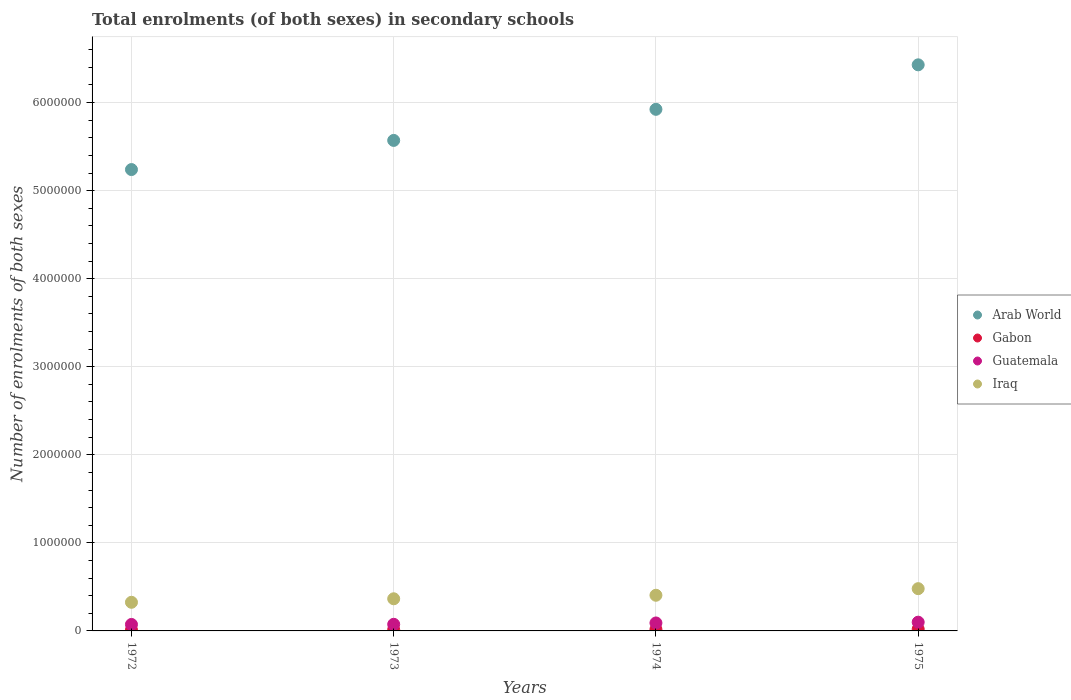How many different coloured dotlines are there?
Provide a succinct answer. 4. Is the number of dotlines equal to the number of legend labels?
Offer a terse response. Yes. What is the number of enrolments in secondary schools in Guatemala in 1974?
Your response must be concise. 9.05e+04. Across all years, what is the maximum number of enrolments in secondary schools in Guatemala?
Give a very brief answer. 9.92e+04. Across all years, what is the minimum number of enrolments in secondary schools in Guatemala?
Your answer should be very brief. 7.35e+04. In which year was the number of enrolments in secondary schools in Arab World maximum?
Make the answer very short. 1975. In which year was the number of enrolments in secondary schools in Arab World minimum?
Your answer should be very brief. 1972. What is the total number of enrolments in secondary schools in Gabon in the graph?
Your answer should be compact. 6.45e+04. What is the difference between the number of enrolments in secondary schools in Iraq in 1972 and that in 1975?
Provide a succinct answer. -1.55e+05. What is the difference between the number of enrolments in secondary schools in Arab World in 1973 and the number of enrolments in secondary schools in Gabon in 1975?
Ensure brevity in your answer.  5.55e+06. What is the average number of enrolments in secondary schools in Arab World per year?
Provide a succinct answer. 5.79e+06. In the year 1974, what is the difference between the number of enrolments in secondary schools in Arab World and number of enrolments in secondary schools in Iraq?
Ensure brevity in your answer.  5.52e+06. What is the ratio of the number of enrolments in secondary schools in Arab World in 1973 to that in 1975?
Make the answer very short. 0.87. Is the number of enrolments in secondary schools in Gabon in 1972 less than that in 1975?
Your answer should be very brief. Yes. Is the difference between the number of enrolments in secondary schools in Arab World in 1973 and 1974 greater than the difference between the number of enrolments in secondary schools in Iraq in 1973 and 1974?
Ensure brevity in your answer.  No. What is the difference between the highest and the second highest number of enrolments in secondary schools in Arab World?
Your answer should be very brief. 5.05e+05. What is the difference between the highest and the lowest number of enrolments in secondary schools in Guatemala?
Give a very brief answer. 2.57e+04. In how many years, is the number of enrolments in secondary schools in Gabon greater than the average number of enrolments in secondary schools in Gabon taken over all years?
Keep it short and to the point. 2. Is the sum of the number of enrolments in secondary schools in Iraq in 1972 and 1973 greater than the maximum number of enrolments in secondary schools in Gabon across all years?
Your response must be concise. Yes. Does the number of enrolments in secondary schools in Guatemala monotonically increase over the years?
Provide a short and direct response. Yes. Is the number of enrolments in secondary schools in Gabon strictly less than the number of enrolments in secondary schools in Iraq over the years?
Give a very brief answer. Yes. What is the difference between two consecutive major ticks on the Y-axis?
Give a very brief answer. 1.00e+06. Are the values on the major ticks of Y-axis written in scientific E-notation?
Offer a very short reply. No. Does the graph contain grids?
Ensure brevity in your answer.  Yes. How many legend labels are there?
Provide a short and direct response. 4. What is the title of the graph?
Keep it short and to the point. Total enrolments (of both sexes) in secondary schools. Does "Slovenia" appear as one of the legend labels in the graph?
Provide a short and direct response. No. What is the label or title of the X-axis?
Your response must be concise. Years. What is the label or title of the Y-axis?
Make the answer very short. Number of enrolments of both sexes. What is the Number of enrolments of both sexes in Arab World in 1972?
Provide a succinct answer. 5.24e+06. What is the Number of enrolments of both sexes in Gabon in 1972?
Give a very brief answer. 1.15e+04. What is the Number of enrolments of both sexes in Guatemala in 1972?
Your response must be concise. 7.35e+04. What is the Number of enrolments of both sexes of Iraq in 1972?
Make the answer very short. 3.25e+05. What is the Number of enrolments of both sexes of Arab World in 1973?
Your answer should be compact. 5.57e+06. What is the Number of enrolments of both sexes of Gabon in 1973?
Your response must be concise. 1.45e+04. What is the Number of enrolments of both sexes in Guatemala in 1973?
Your response must be concise. 7.52e+04. What is the Number of enrolments of both sexes in Iraq in 1973?
Your response must be concise. 3.65e+05. What is the Number of enrolments of both sexes of Arab World in 1974?
Keep it short and to the point. 5.92e+06. What is the Number of enrolments of both sexes in Gabon in 1974?
Give a very brief answer. 1.75e+04. What is the Number of enrolments of both sexes in Guatemala in 1974?
Ensure brevity in your answer.  9.05e+04. What is the Number of enrolments of both sexes of Iraq in 1974?
Offer a terse response. 4.05e+05. What is the Number of enrolments of both sexes of Arab World in 1975?
Offer a terse response. 6.43e+06. What is the Number of enrolments of both sexes of Gabon in 1975?
Give a very brief answer. 2.10e+04. What is the Number of enrolments of both sexes of Guatemala in 1975?
Your answer should be compact. 9.92e+04. What is the Number of enrolments of both sexes in Iraq in 1975?
Make the answer very short. 4.80e+05. Across all years, what is the maximum Number of enrolments of both sexes of Arab World?
Keep it short and to the point. 6.43e+06. Across all years, what is the maximum Number of enrolments of both sexes of Gabon?
Keep it short and to the point. 2.10e+04. Across all years, what is the maximum Number of enrolments of both sexes in Guatemala?
Provide a short and direct response. 9.92e+04. Across all years, what is the maximum Number of enrolments of both sexes in Iraq?
Your response must be concise. 4.80e+05. Across all years, what is the minimum Number of enrolments of both sexes of Arab World?
Ensure brevity in your answer.  5.24e+06. Across all years, what is the minimum Number of enrolments of both sexes in Gabon?
Your answer should be very brief. 1.15e+04. Across all years, what is the minimum Number of enrolments of both sexes of Guatemala?
Ensure brevity in your answer.  7.35e+04. Across all years, what is the minimum Number of enrolments of both sexes of Iraq?
Ensure brevity in your answer.  3.25e+05. What is the total Number of enrolments of both sexes of Arab World in the graph?
Provide a succinct answer. 2.32e+07. What is the total Number of enrolments of both sexes in Gabon in the graph?
Ensure brevity in your answer.  6.45e+04. What is the total Number of enrolments of both sexes of Guatemala in the graph?
Provide a succinct answer. 3.38e+05. What is the total Number of enrolments of both sexes of Iraq in the graph?
Provide a short and direct response. 1.57e+06. What is the difference between the Number of enrolments of both sexes in Arab World in 1972 and that in 1973?
Provide a short and direct response. -3.31e+05. What is the difference between the Number of enrolments of both sexes in Gabon in 1972 and that in 1973?
Offer a terse response. -2998. What is the difference between the Number of enrolments of both sexes in Guatemala in 1972 and that in 1973?
Ensure brevity in your answer.  -1649. What is the difference between the Number of enrolments of both sexes of Iraq in 1972 and that in 1973?
Keep it short and to the point. -3.99e+04. What is the difference between the Number of enrolments of both sexes in Arab World in 1972 and that in 1974?
Offer a very short reply. -6.84e+05. What is the difference between the Number of enrolments of both sexes in Gabon in 1972 and that in 1974?
Provide a succinct answer. -6083. What is the difference between the Number of enrolments of both sexes in Guatemala in 1972 and that in 1974?
Make the answer very short. -1.70e+04. What is the difference between the Number of enrolments of both sexes in Iraq in 1972 and that in 1974?
Keep it short and to the point. -7.99e+04. What is the difference between the Number of enrolments of both sexes of Arab World in 1972 and that in 1975?
Your answer should be compact. -1.19e+06. What is the difference between the Number of enrolments of both sexes of Gabon in 1972 and that in 1975?
Provide a succinct answer. -9538. What is the difference between the Number of enrolments of both sexes in Guatemala in 1972 and that in 1975?
Provide a short and direct response. -2.57e+04. What is the difference between the Number of enrolments of both sexes in Iraq in 1972 and that in 1975?
Ensure brevity in your answer.  -1.55e+05. What is the difference between the Number of enrolments of both sexes in Arab World in 1973 and that in 1974?
Offer a terse response. -3.53e+05. What is the difference between the Number of enrolments of both sexes in Gabon in 1973 and that in 1974?
Offer a terse response. -3085. What is the difference between the Number of enrolments of both sexes in Guatemala in 1973 and that in 1974?
Your answer should be compact. -1.53e+04. What is the difference between the Number of enrolments of both sexes of Iraq in 1973 and that in 1974?
Your answer should be very brief. -4.00e+04. What is the difference between the Number of enrolments of both sexes in Arab World in 1973 and that in 1975?
Keep it short and to the point. -8.58e+05. What is the difference between the Number of enrolments of both sexes in Gabon in 1973 and that in 1975?
Offer a very short reply. -6540. What is the difference between the Number of enrolments of both sexes in Guatemala in 1973 and that in 1975?
Give a very brief answer. -2.41e+04. What is the difference between the Number of enrolments of both sexes of Iraq in 1973 and that in 1975?
Ensure brevity in your answer.  -1.15e+05. What is the difference between the Number of enrolments of both sexes in Arab World in 1974 and that in 1975?
Give a very brief answer. -5.05e+05. What is the difference between the Number of enrolments of both sexes in Gabon in 1974 and that in 1975?
Give a very brief answer. -3455. What is the difference between the Number of enrolments of both sexes of Guatemala in 1974 and that in 1975?
Your answer should be very brief. -8771. What is the difference between the Number of enrolments of both sexes of Iraq in 1974 and that in 1975?
Ensure brevity in your answer.  -7.49e+04. What is the difference between the Number of enrolments of both sexes of Arab World in 1972 and the Number of enrolments of both sexes of Gabon in 1973?
Your answer should be compact. 5.22e+06. What is the difference between the Number of enrolments of both sexes of Arab World in 1972 and the Number of enrolments of both sexes of Guatemala in 1973?
Your answer should be compact. 5.16e+06. What is the difference between the Number of enrolments of both sexes of Arab World in 1972 and the Number of enrolments of both sexes of Iraq in 1973?
Your answer should be very brief. 4.87e+06. What is the difference between the Number of enrolments of both sexes of Gabon in 1972 and the Number of enrolments of both sexes of Guatemala in 1973?
Keep it short and to the point. -6.37e+04. What is the difference between the Number of enrolments of both sexes in Gabon in 1972 and the Number of enrolments of both sexes in Iraq in 1973?
Your answer should be compact. -3.54e+05. What is the difference between the Number of enrolments of both sexes of Guatemala in 1972 and the Number of enrolments of both sexes of Iraq in 1973?
Provide a short and direct response. -2.91e+05. What is the difference between the Number of enrolments of both sexes of Arab World in 1972 and the Number of enrolments of both sexes of Gabon in 1974?
Keep it short and to the point. 5.22e+06. What is the difference between the Number of enrolments of both sexes of Arab World in 1972 and the Number of enrolments of both sexes of Guatemala in 1974?
Provide a short and direct response. 5.15e+06. What is the difference between the Number of enrolments of both sexes of Arab World in 1972 and the Number of enrolments of both sexes of Iraq in 1974?
Provide a short and direct response. 4.83e+06. What is the difference between the Number of enrolments of both sexes in Gabon in 1972 and the Number of enrolments of both sexes in Guatemala in 1974?
Make the answer very short. -7.90e+04. What is the difference between the Number of enrolments of both sexes of Gabon in 1972 and the Number of enrolments of both sexes of Iraq in 1974?
Provide a short and direct response. -3.94e+05. What is the difference between the Number of enrolments of both sexes of Guatemala in 1972 and the Number of enrolments of both sexes of Iraq in 1974?
Provide a succinct answer. -3.32e+05. What is the difference between the Number of enrolments of both sexes in Arab World in 1972 and the Number of enrolments of both sexes in Gabon in 1975?
Your answer should be very brief. 5.22e+06. What is the difference between the Number of enrolments of both sexes in Arab World in 1972 and the Number of enrolments of both sexes in Guatemala in 1975?
Ensure brevity in your answer.  5.14e+06. What is the difference between the Number of enrolments of both sexes in Arab World in 1972 and the Number of enrolments of both sexes in Iraq in 1975?
Keep it short and to the point. 4.76e+06. What is the difference between the Number of enrolments of both sexes in Gabon in 1972 and the Number of enrolments of both sexes in Guatemala in 1975?
Your answer should be compact. -8.78e+04. What is the difference between the Number of enrolments of both sexes of Gabon in 1972 and the Number of enrolments of both sexes of Iraq in 1975?
Give a very brief answer. -4.68e+05. What is the difference between the Number of enrolments of both sexes in Guatemala in 1972 and the Number of enrolments of both sexes in Iraq in 1975?
Provide a short and direct response. -4.06e+05. What is the difference between the Number of enrolments of both sexes of Arab World in 1973 and the Number of enrolments of both sexes of Gabon in 1974?
Make the answer very short. 5.55e+06. What is the difference between the Number of enrolments of both sexes of Arab World in 1973 and the Number of enrolments of both sexes of Guatemala in 1974?
Your response must be concise. 5.48e+06. What is the difference between the Number of enrolments of both sexes of Arab World in 1973 and the Number of enrolments of both sexes of Iraq in 1974?
Keep it short and to the point. 5.17e+06. What is the difference between the Number of enrolments of both sexes in Gabon in 1973 and the Number of enrolments of both sexes in Guatemala in 1974?
Provide a short and direct response. -7.60e+04. What is the difference between the Number of enrolments of both sexes of Gabon in 1973 and the Number of enrolments of both sexes of Iraq in 1974?
Your answer should be very brief. -3.91e+05. What is the difference between the Number of enrolments of both sexes of Guatemala in 1973 and the Number of enrolments of both sexes of Iraq in 1974?
Offer a terse response. -3.30e+05. What is the difference between the Number of enrolments of both sexes in Arab World in 1973 and the Number of enrolments of both sexes in Gabon in 1975?
Your answer should be very brief. 5.55e+06. What is the difference between the Number of enrolments of both sexes in Arab World in 1973 and the Number of enrolments of both sexes in Guatemala in 1975?
Make the answer very short. 5.47e+06. What is the difference between the Number of enrolments of both sexes in Arab World in 1973 and the Number of enrolments of both sexes in Iraq in 1975?
Give a very brief answer. 5.09e+06. What is the difference between the Number of enrolments of both sexes in Gabon in 1973 and the Number of enrolments of both sexes in Guatemala in 1975?
Offer a terse response. -8.48e+04. What is the difference between the Number of enrolments of both sexes in Gabon in 1973 and the Number of enrolments of both sexes in Iraq in 1975?
Provide a succinct answer. -4.65e+05. What is the difference between the Number of enrolments of both sexes of Guatemala in 1973 and the Number of enrolments of both sexes of Iraq in 1975?
Offer a very short reply. -4.05e+05. What is the difference between the Number of enrolments of both sexes in Arab World in 1974 and the Number of enrolments of both sexes in Gabon in 1975?
Give a very brief answer. 5.90e+06. What is the difference between the Number of enrolments of both sexes in Arab World in 1974 and the Number of enrolments of both sexes in Guatemala in 1975?
Your answer should be very brief. 5.82e+06. What is the difference between the Number of enrolments of both sexes of Arab World in 1974 and the Number of enrolments of both sexes of Iraq in 1975?
Your response must be concise. 5.44e+06. What is the difference between the Number of enrolments of both sexes in Gabon in 1974 and the Number of enrolments of both sexes in Guatemala in 1975?
Ensure brevity in your answer.  -8.17e+04. What is the difference between the Number of enrolments of both sexes in Gabon in 1974 and the Number of enrolments of both sexes in Iraq in 1975?
Provide a succinct answer. -4.62e+05. What is the difference between the Number of enrolments of both sexes of Guatemala in 1974 and the Number of enrolments of both sexes of Iraq in 1975?
Give a very brief answer. -3.89e+05. What is the average Number of enrolments of both sexes in Arab World per year?
Offer a very short reply. 5.79e+06. What is the average Number of enrolments of both sexes of Gabon per year?
Make the answer very short. 1.61e+04. What is the average Number of enrolments of both sexes of Guatemala per year?
Offer a terse response. 8.46e+04. What is the average Number of enrolments of both sexes of Iraq per year?
Ensure brevity in your answer.  3.94e+05. In the year 1972, what is the difference between the Number of enrolments of both sexes of Arab World and Number of enrolments of both sexes of Gabon?
Your answer should be very brief. 5.23e+06. In the year 1972, what is the difference between the Number of enrolments of both sexes in Arab World and Number of enrolments of both sexes in Guatemala?
Your answer should be compact. 5.17e+06. In the year 1972, what is the difference between the Number of enrolments of both sexes of Arab World and Number of enrolments of both sexes of Iraq?
Your response must be concise. 4.91e+06. In the year 1972, what is the difference between the Number of enrolments of both sexes in Gabon and Number of enrolments of both sexes in Guatemala?
Keep it short and to the point. -6.20e+04. In the year 1972, what is the difference between the Number of enrolments of both sexes in Gabon and Number of enrolments of both sexes in Iraq?
Your response must be concise. -3.14e+05. In the year 1972, what is the difference between the Number of enrolments of both sexes in Guatemala and Number of enrolments of both sexes in Iraq?
Give a very brief answer. -2.52e+05. In the year 1973, what is the difference between the Number of enrolments of both sexes of Arab World and Number of enrolments of both sexes of Gabon?
Your answer should be very brief. 5.56e+06. In the year 1973, what is the difference between the Number of enrolments of both sexes of Arab World and Number of enrolments of both sexes of Guatemala?
Make the answer very short. 5.49e+06. In the year 1973, what is the difference between the Number of enrolments of both sexes of Arab World and Number of enrolments of both sexes of Iraq?
Keep it short and to the point. 5.21e+06. In the year 1973, what is the difference between the Number of enrolments of both sexes of Gabon and Number of enrolments of both sexes of Guatemala?
Your answer should be very brief. -6.07e+04. In the year 1973, what is the difference between the Number of enrolments of both sexes in Gabon and Number of enrolments of both sexes in Iraq?
Your answer should be very brief. -3.51e+05. In the year 1973, what is the difference between the Number of enrolments of both sexes in Guatemala and Number of enrolments of both sexes in Iraq?
Offer a terse response. -2.90e+05. In the year 1974, what is the difference between the Number of enrolments of both sexes of Arab World and Number of enrolments of both sexes of Gabon?
Provide a short and direct response. 5.91e+06. In the year 1974, what is the difference between the Number of enrolments of both sexes in Arab World and Number of enrolments of both sexes in Guatemala?
Offer a terse response. 5.83e+06. In the year 1974, what is the difference between the Number of enrolments of both sexes of Arab World and Number of enrolments of both sexes of Iraq?
Your answer should be compact. 5.52e+06. In the year 1974, what is the difference between the Number of enrolments of both sexes of Gabon and Number of enrolments of both sexes of Guatemala?
Provide a succinct answer. -7.29e+04. In the year 1974, what is the difference between the Number of enrolments of both sexes of Gabon and Number of enrolments of both sexes of Iraq?
Your answer should be very brief. -3.87e+05. In the year 1974, what is the difference between the Number of enrolments of both sexes in Guatemala and Number of enrolments of both sexes in Iraq?
Your answer should be very brief. -3.15e+05. In the year 1975, what is the difference between the Number of enrolments of both sexes of Arab World and Number of enrolments of both sexes of Gabon?
Offer a terse response. 6.41e+06. In the year 1975, what is the difference between the Number of enrolments of both sexes of Arab World and Number of enrolments of both sexes of Guatemala?
Your answer should be compact. 6.33e+06. In the year 1975, what is the difference between the Number of enrolments of both sexes of Arab World and Number of enrolments of both sexes of Iraq?
Offer a very short reply. 5.95e+06. In the year 1975, what is the difference between the Number of enrolments of both sexes of Gabon and Number of enrolments of both sexes of Guatemala?
Provide a succinct answer. -7.82e+04. In the year 1975, what is the difference between the Number of enrolments of both sexes in Gabon and Number of enrolments of both sexes in Iraq?
Give a very brief answer. -4.59e+05. In the year 1975, what is the difference between the Number of enrolments of both sexes in Guatemala and Number of enrolments of both sexes in Iraq?
Ensure brevity in your answer.  -3.81e+05. What is the ratio of the Number of enrolments of both sexes in Arab World in 1972 to that in 1973?
Give a very brief answer. 0.94. What is the ratio of the Number of enrolments of both sexes of Gabon in 1972 to that in 1973?
Provide a succinct answer. 0.79. What is the ratio of the Number of enrolments of both sexes of Guatemala in 1972 to that in 1973?
Provide a succinct answer. 0.98. What is the ratio of the Number of enrolments of both sexes of Iraq in 1972 to that in 1973?
Make the answer very short. 0.89. What is the ratio of the Number of enrolments of both sexes in Arab World in 1972 to that in 1974?
Keep it short and to the point. 0.88. What is the ratio of the Number of enrolments of both sexes of Gabon in 1972 to that in 1974?
Ensure brevity in your answer.  0.65. What is the ratio of the Number of enrolments of both sexes of Guatemala in 1972 to that in 1974?
Provide a short and direct response. 0.81. What is the ratio of the Number of enrolments of both sexes of Iraq in 1972 to that in 1974?
Your answer should be compact. 0.8. What is the ratio of the Number of enrolments of both sexes in Arab World in 1972 to that in 1975?
Provide a short and direct response. 0.81. What is the ratio of the Number of enrolments of both sexes of Gabon in 1972 to that in 1975?
Ensure brevity in your answer.  0.55. What is the ratio of the Number of enrolments of both sexes in Guatemala in 1972 to that in 1975?
Give a very brief answer. 0.74. What is the ratio of the Number of enrolments of both sexes in Iraq in 1972 to that in 1975?
Provide a succinct answer. 0.68. What is the ratio of the Number of enrolments of both sexes in Arab World in 1973 to that in 1974?
Your response must be concise. 0.94. What is the ratio of the Number of enrolments of both sexes in Gabon in 1973 to that in 1974?
Provide a short and direct response. 0.82. What is the ratio of the Number of enrolments of both sexes in Guatemala in 1973 to that in 1974?
Keep it short and to the point. 0.83. What is the ratio of the Number of enrolments of both sexes of Iraq in 1973 to that in 1974?
Provide a succinct answer. 0.9. What is the ratio of the Number of enrolments of both sexes in Arab World in 1973 to that in 1975?
Make the answer very short. 0.87. What is the ratio of the Number of enrolments of both sexes of Gabon in 1973 to that in 1975?
Provide a short and direct response. 0.69. What is the ratio of the Number of enrolments of both sexes in Guatemala in 1973 to that in 1975?
Ensure brevity in your answer.  0.76. What is the ratio of the Number of enrolments of both sexes of Iraq in 1973 to that in 1975?
Your answer should be compact. 0.76. What is the ratio of the Number of enrolments of both sexes of Arab World in 1974 to that in 1975?
Offer a terse response. 0.92. What is the ratio of the Number of enrolments of both sexes of Gabon in 1974 to that in 1975?
Make the answer very short. 0.84. What is the ratio of the Number of enrolments of both sexes of Guatemala in 1974 to that in 1975?
Provide a short and direct response. 0.91. What is the ratio of the Number of enrolments of both sexes in Iraq in 1974 to that in 1975?
Your answer should be compact. 0.84. What is the difference between the highest and the second highest Number of enrolments of both sexes in Arab World?
Provide a short and direct response. 5.05e+05. What is the difference between the highest and the second highest Number of enrolments of both sexes of Gabon?
Provide a succinct answer. 3455. What is the difference between the highest and the second highest Number of enrolments of both sexes in Guatemala?
Provide a short and direct response. 8771. What is the difference between the highest and the second highest Number of enrolments of both sexes of Iraq?
Ensure brevity in your answer.  7.49e+04. What is the difference between the highest and the lowest Number of enrolments of both sexes in Arab World?
Make the answer very short. 1.19e+06. What is the difference between the highest and the lowest Number of enrolments of both sexes in Gabon?
Provide a short and direct response. 9538. What is the difference between the highest and the lowest Number of enrolments of both sexes in Guatemala?
Your answer should be compact. 2.57e+04. What is the difference between the highest and the lowest Number of enrolments of both sexes of Iraq?
Ensure brevity in your answer.  1.55e+05. 